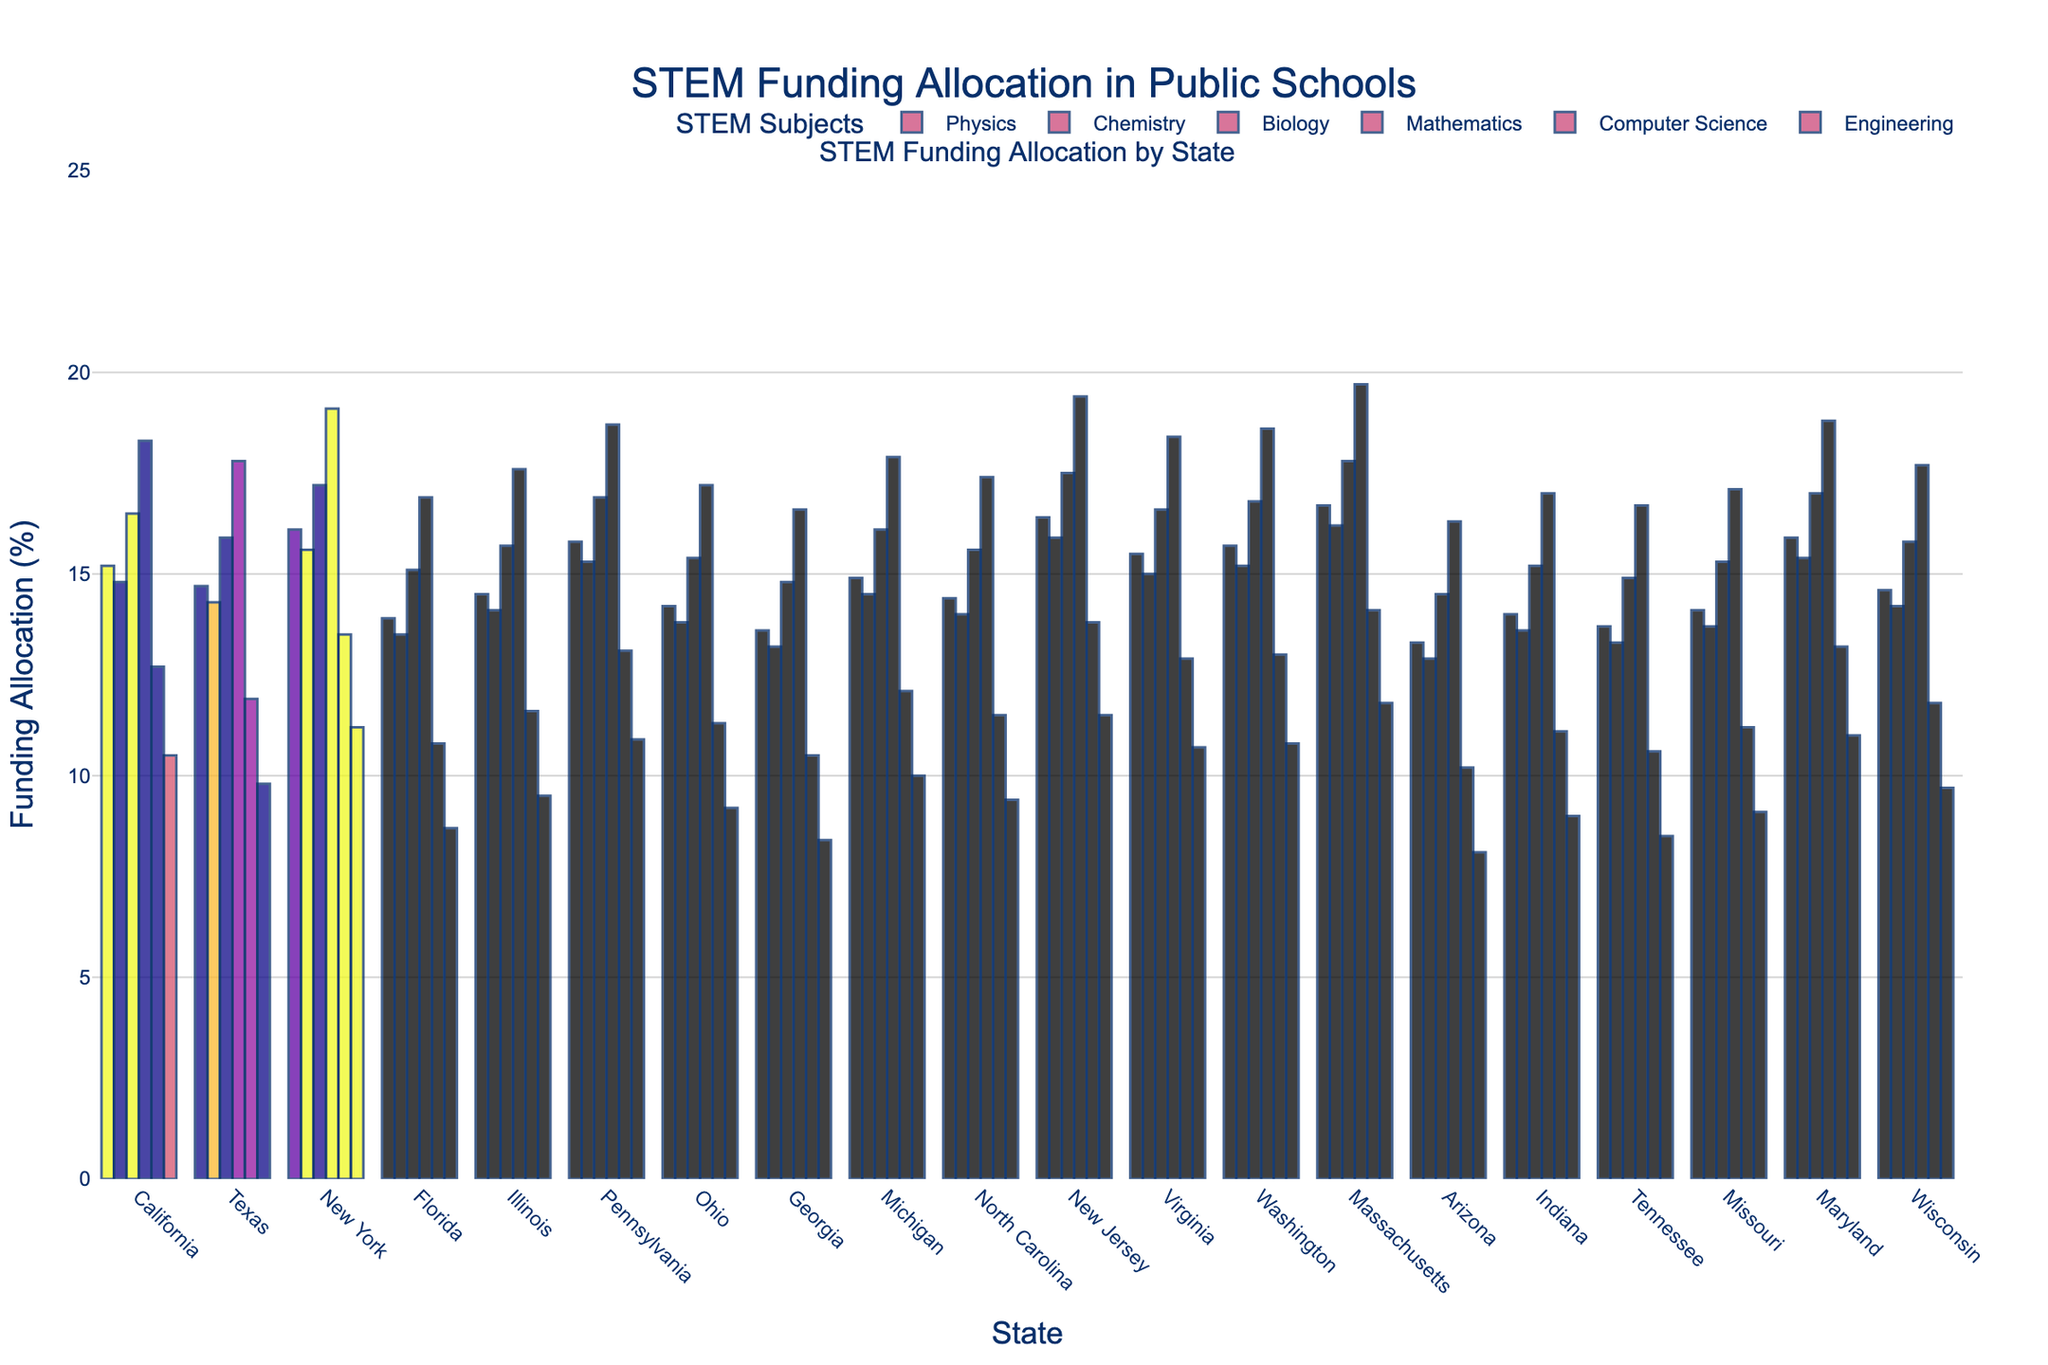Which state has allocated the highest percentage of funding to Mathematics? First, identify the bar corresponding to Mathematics for each state by color and height. The highest bar for Mathematics is in Massachusetts.
Answer: Massachusetts In which subject does Georgia allocate the least funding? Compare the height of the bars for each subject in Georgia. The shortest bar represents Engineering.
Answer: Engineering What is the total percentage of funding allocated to Biology and Computer Science in Ohio? Find the respective bars for Biology and Computer Science in Ohio, read their values, and sum them up (15.4 + 11.3).
Answer: 26.7 Which two states have the closest funding allocation percentages for Chemistry, and what are those percentages? Look for bars of similar height in the Chemistry category. California and Texas have similar heights, with values of 14.8% and 14.3%, respectively.
Answer: California (14.8%), Texas (14.3%) Is the funding allocation for Physics in New Jersey greater than or less than that in Pennsylvania? Compare the height of the Physics bars in New Jersey and Pennsylvania. New Jersey's allocation for Physics (16.4%) is greater than Pennsylvania's (15.8%).
Answer: Greater than What is the average funding allocation for Computer Science across all states? Sum up all the percentages of Computer Science across the states and divide by the number of states. The total is (12.7 + 11.9 + 13.5 + 10.8 + 11.6 + 13.1 + 11.3 + 10.5 + 12.1 + 11.5 + 13.8 + 12.9 + 13.0 + 14.1 + 10.2 + 11.1 + 10.6 + 11.2 + 13.2 + 11.8) = 232.8. There are 20 states, so 232.8 / 20 = 11.64.
Answer: 11.64 Which state has the highest combined funding allocation for Physics and Engineering? Add up the values for Physics and Engineering for each state. The highest combined value is for Massachusetts (16.7 + 11.8 = 28.5).
Answer: Massachusetts 